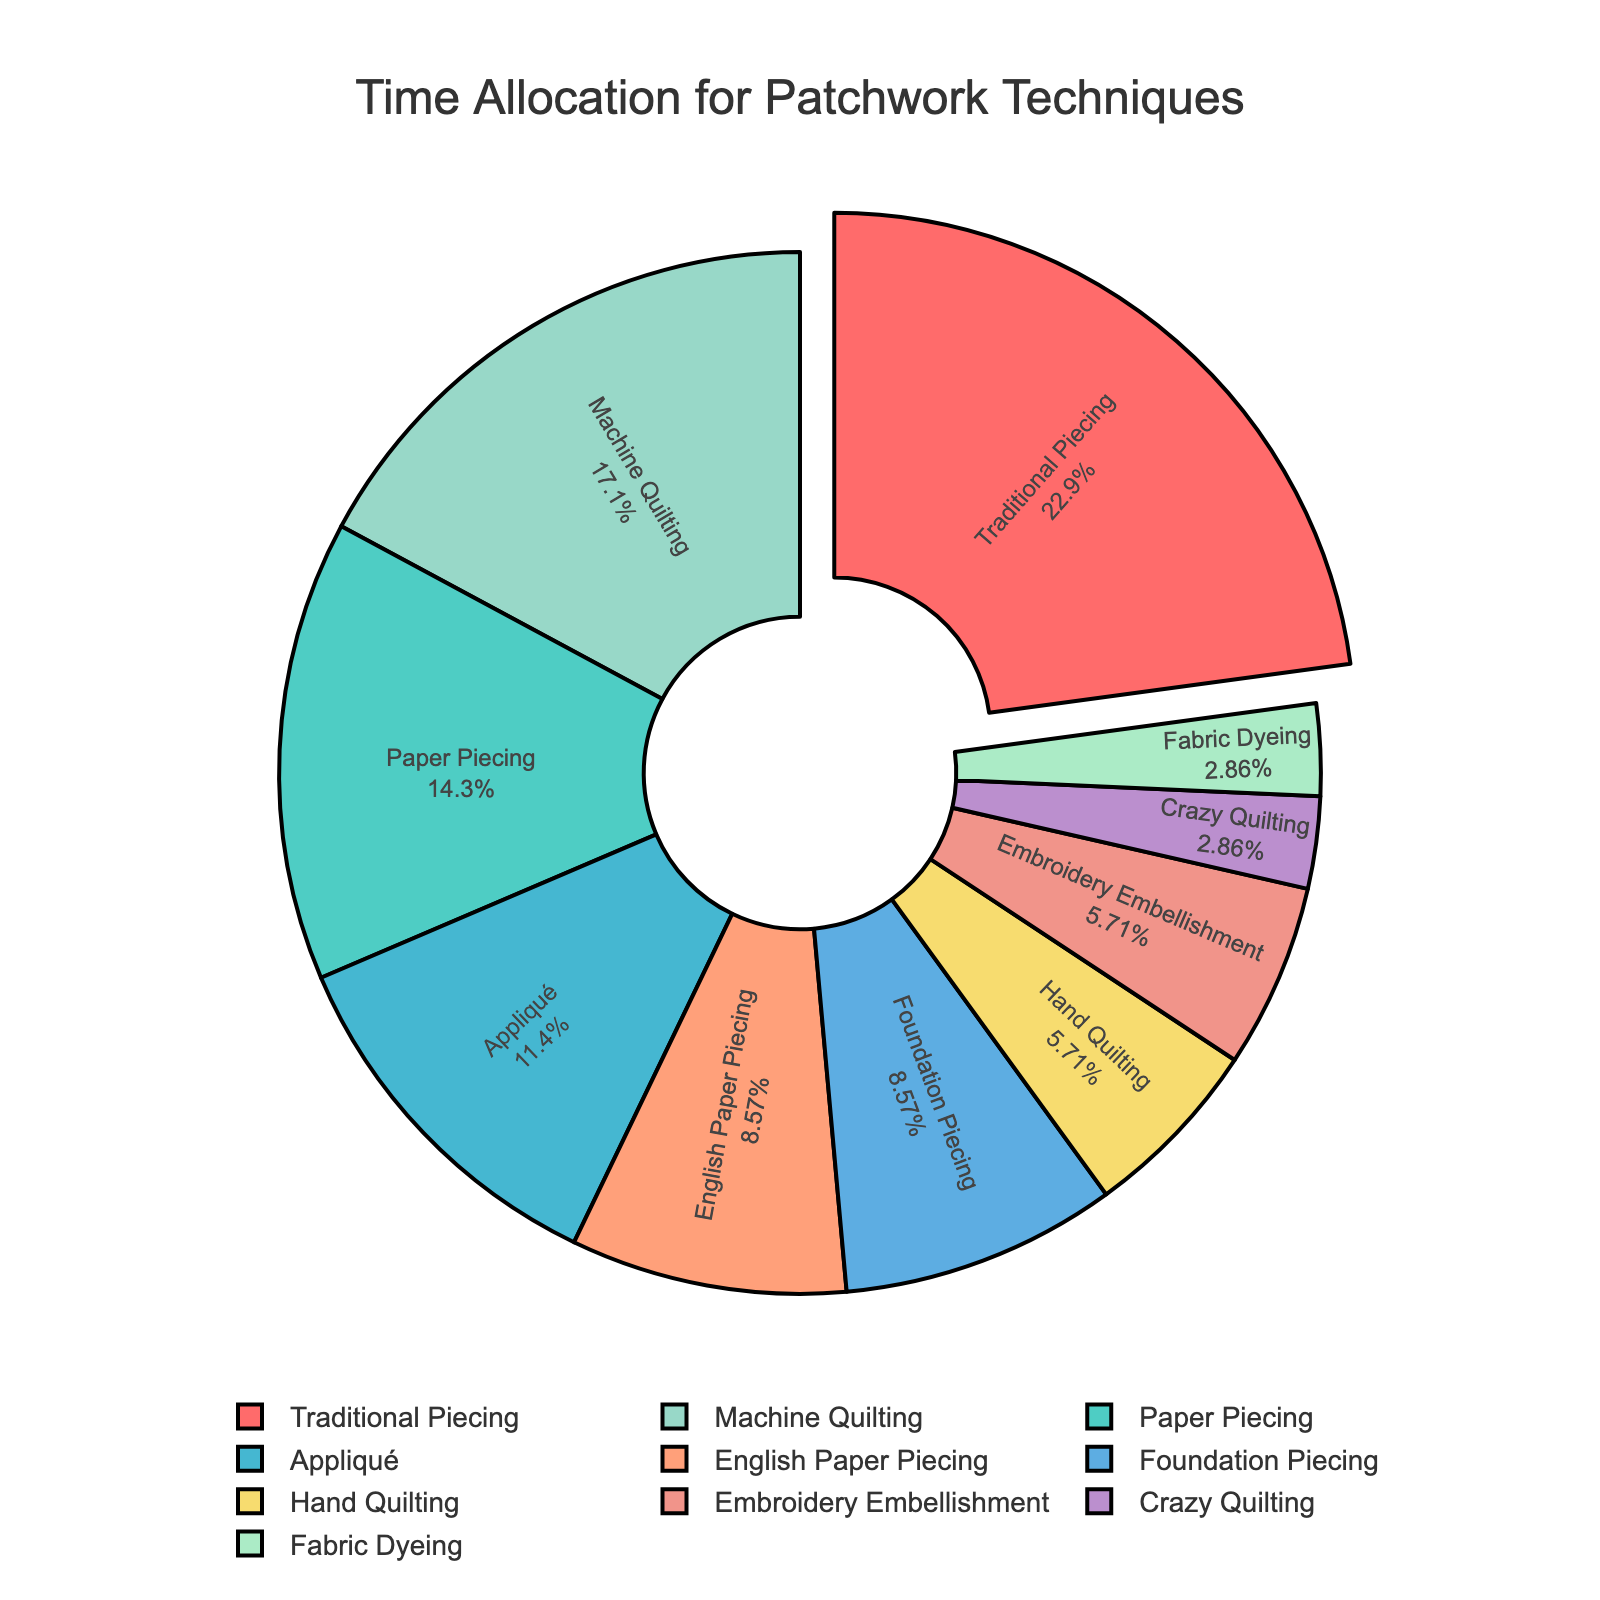What percentage of the time is dedicated to Traditional Piecing? Based on the pie chart, identify the label "Traditional Piecing" and observe its corresponding percentage value.
Answer: 26.7% Which technique is allocated the least amount of time? Look for the smallest segment in the pie chart and refer to its label.
Answer: Crazy Quilting and Fabric Dyeing How many hours per week are spent on Machine Quilting compared to Hand Quilting? Observe the number of hours allocated to Machine Quilting and Hand Quilting in the chart, then find their difference. Machine Quilting has 6 hours, and Hand Quilting has 2 hours.
Answer: 4 hours more Which technique has the largest segment, and how much time does it take per week? Identify the largest segment in the pie chart and note its label and corresponding hours per week.
Answer: Traditional Piecing, 8 hours per week How much more time is spent on Paper Piecing than on English Paper Piecing? Locate the segments for Paper Piecing and English Paper Piecing, identify their hours, and calculate the difference. Paper Piecing has 5 hours, while English Paper Piecing has 3 hours.
Answer: 2 hours more What is the combined weekly time spent on Embroidery Embellishment and Appliqué? Identify the hours per week for Embroidery Embellishment and Appliqué from the chart and sum them up. Embroidery Embellishment is 2 hours and Appliqué is 4 hours.
Answer: 6 hours Which techniques have equal weekly time allocations? Observe and compare segment sizes and their labels to find those with equal hours per week.
Answer: English Paper Piecing and Foundation Piecing (3 hours each); Hand Quilting and Embroidery Embellishment (2 hours each); Crazy Quilting and Fabric Dyeing (1 hour each) What percentage of total weekly hours is allocated to Hand Quilting? Identify the segment for Hand Quilting and read off the percentage indicated within the pie chart.
Answer: 6.7% If we combine the segments of Appliqué and Machine Quilting, what fraction of the chart do they represent together? Add the hours for Appliqué (4) and Machine Quilting (6) to get a total, then divide by the total number of hours (35). 10 hours out of 35 hours.
Answer: 10/35 or 2/7 